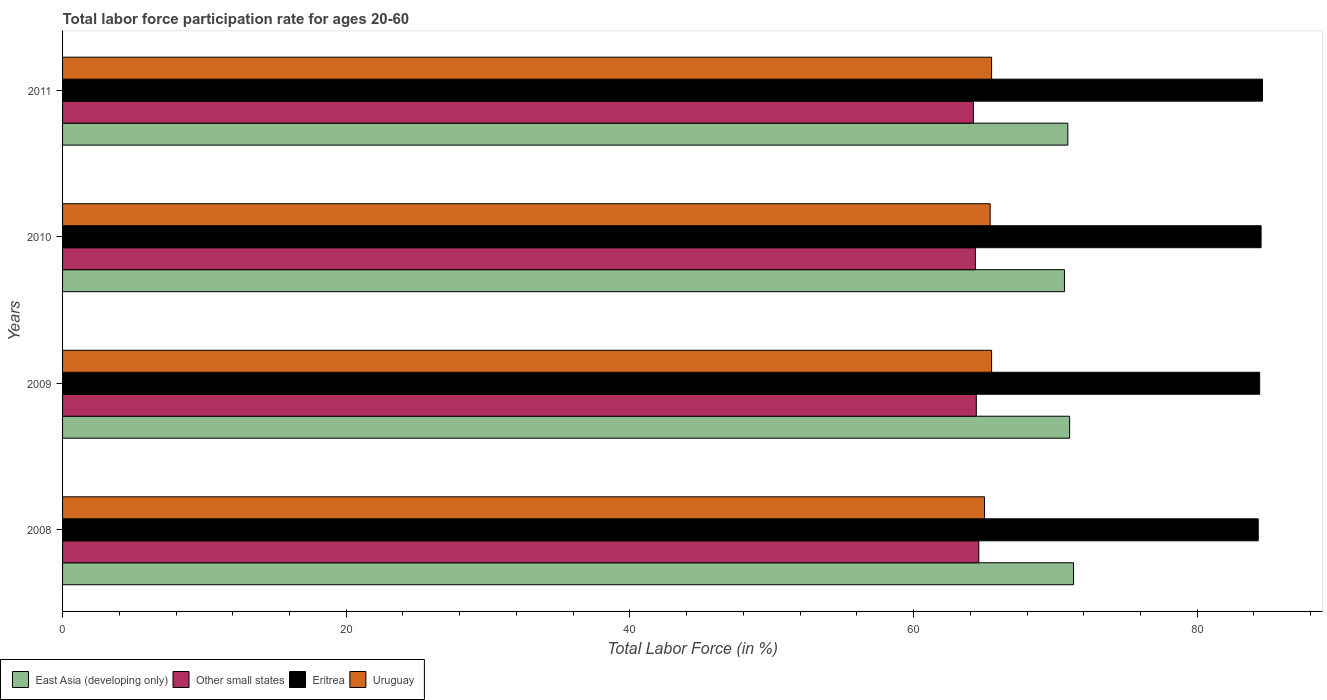How many groups of bars are there?
Make the answer very short. 4. Are the number of bars per tick equal to the number of legend labels?
Offer a terse response. Yes. Are the number of bars on each tick of the Y-axis equal?
Your response must be concise. Yes. How many bars are there on the 1st tick from the top?
Provide a short and direct response. 4. How many bars are there on the 4th tick from the bottom?
Offer a very short reply. 4. What is the label of the 4th group of bars from the top?
Ensure brevity in your answer.  2008. What is the labor force participation rate in East Asia (developing only) in 2011?
Ensure brevity in your answer.  70.87. Across all years, what is the maximum labor force participation rate in Eritrea?
Provide a short and direct response. 84.6. Across all years, what is the minimum labor force participation rate in Other small states?
Your response must be concise. 64.21. In which year was the labor force participation rate in Other small states minimum?
Ensure brevity in your answer.  2011. What is the total labor force participation rate in Eritrea in the graph?
Your answer should be compact. 337.8. What is the difference between the labor force participation rate in Eritrea in 2008 and that in 2009?
Your answer should be compact. -0.1. What is the difference between the labor force participation rate in East Asia (developing only) in 2010 and the labor force participation rate in Eritrea in 2011?
Offer a very short reply. -13.96. What is the average labor force participation rate in Uruguay per year?
Make the answer very short. 65.35. In the year 2009, what is the difference between the labor force participation rate in Other small states and labor force participation rate in East Asia (developing only)?
Your answer should be very brief. -6.58. What is the ratio of the labor force participation rate in Other small states in 2008 to that in 2009?
Your answer should be very brief. 1. Is the labor force participation rate in Other small states in 2009 less than that in 2011?
Keep it short and to the point. No. What is the difference between the highest and the second highest labor force participation rate in East Asia (developing only)?
Provide a short and direct response. 0.28. What is the difference between the highest and the lowest labor force participation rate in Uruguay?
Your answer should be very brief. 0.5. In how many years, is the labor force participation rate in Uruguay greater than the average labor force participation rate in Uruguay taken over all years?
Give a very brief answer. 3. Is the sum of the labor force participation rate in East Asia (developing only) in 2008 and 2009 greater than the maximum labor force participation rate in Uruguay across all years?
Keep it short and to the point. Yes. What does the 2nd bar from the top in 2009 represents?
Give a very brief answer. Eritrea. What does the 4th bar from the bottom in 2010 represents?
Give a very brief answer. Uruguay. Is it the case that in every year, the sum of the labor force participation rate in Other small states and labor force participation rate in East Asia (developing only) is greater than the labor force participation rate in Eritrea?
Offer a very short reply. Yes. How many bars are there?
Ensure brevity in your answer.  16. Are all the bars in the graph horizontal?
Give a very brief answer. Yes. How many years are there in the graph?
Make the answer very short. 4. What is the difference between two consecutive major ticks on the X-axis?
Give a very brief answer. 20. Are the values on the major ticks of X-axis written in scientific E-notation?
Your answer should be very brief. No. Where does the legend appear in the graph?
Offer a terse response. Bottom left. What is the title of the graph?
Your answer should be very brief. Total labor force participation rate for ages 20-60. What is the label or title of the Y-axis?
Offer a very short reply. Years. What is the Total Labor Force (in %) in East Asia (developing only) in 2008?
Keep it short and to the point. 71.28. What is the Total Labor Force (in %) of Other small states in 2008?
Your answer should be compact. 64.6. What is the Total Labor Force (in %) of Eritrea in 2008?
Make the answer very short. 84.3. What is the Total Labor Force (in %) in East Asia (developing only) in 2009?
Ensure brevity in your answer.  71. What is the Total Labor Force (in %) in Other small states in 2009?
Provide a short and direct response. 64.42. What is the Total Labor Force (in %) of Eritrea in 2009?
Provide a succinct answer. 84.4. What is the Total Labor Force (in %) of Uruguay in 2009?
Make the answer very short. 65.5. What is the Total Labor Force (in %) in East Asia (developing only) in 2010?
Keep it short and to the point. 70.64. What is the Total Labor Force (in %) of Other small states in 2010?
Offer a terse response. 64.36. What is the Total Labor Force (in %) in Eritrea in 2010?
Offer a terse response. 84.5. What is the Total Labor Force (in %) in Uruguay in 2010?
Provide a succinct answer. 65.4. What is the Total Labor Force (in %) of East Asia (developing only) in 2011?
Offer a terse response. 70.87. What is the Total Labor Force (in %) in Other small states in 2011?
Offer a very short reply. 64.21. What is the Total Labor Force (in %) of Eritrea in 2011?
Your response must be concise. 84.6. What is the Total Labor Force (in %) in Uruguay in 2011?
Ensure brevity in your answer.  65.5. Across all years, what is the maximum Total Labor Force (in %) in East Asia (developing only)?
Provide a short and direct response. 71.28. Across all years, what is the maximum Total Labor Force (in %) in Other small states?
Ensure brevity in your answer.  64.6. Across all years, what is the maximum Total Labor Force (in %) of Eritrea?
Give a very brief answer. 84.6. Across all years, what is the maximum Total Labor Force (in %) of Uruguay?
Give a very brief answer. 65.5. Across all years, what is the minimum Total Labor Force (in %) of East Asia (developing only)?
Provide a short and direct response. 70.64. Across all years, what is the minimum Total Labor Force (in %) in Other small states?
Keep it short and to the point. 64.21. Across all years, what is the minimum Total Labor Force (in %) in Eritrea?
Your answer should be very brief. 84.3. Across all years, what is the minimum Total Labor Force (in %) in Uruguay?
Provide a succinct answer. 65. What is the total Total Labor Force (in %) of East Asia (developing only) in the graph?
Ensure brevity in your answer.  283.79. What is the total Total Labor Force (in %) in Other small states in the graph?
Your answer should be compact. 257.6. What is the total Total Labor Force (in %) in Eritrea in the graph?
Provide a succinct answer. 337.8. What is the total Total Labor Force (in %) in Uruguay in the graph?
Your answer should be compact. 261.4. What is the difference between the Total Labor Force (in %) of East Asia (developing only) in 2008 and that in 2009?
Your answer should be compact. 0.28. What is the difference between the Total Labor Force (in %) of Other small states in 2008 and that in 2009?
Your response must be concise. 0.17. What is the difference between the Total Labor Force (in %) in East Asia (developing only) in 2008 and that in 2010?
Your answer should be very brief. 0.64. What is the difference between the Total Labor Force (in %) in Other small states in 2008 and that in 2010?
Make the answer very short. 0.24. What is the difference between the Total Labor Force (in %) in Eritrea in 2008 and that in 2010?
Offer a very short reply. -0.2. What is the difference between the Total Labor Force (in %) in Uruguay in 2008 and that in 2010?
Give a very brief answer. -0.4. What is the difference between the Total Labor Force (in %) of East Asia (developing only) in 2008 and that in 2011?
Provide a succinct answer. 0.4. What is the difference between the Total Labor Force (in %) in Other small states in 2008 and that in 2011?
Provide a short and direct response. 0.38. What is the difference between the Total Labor Force (in %) in East Asia (developing only) in 2009 and that in 2010?
Offer a terse response. 0.36. What is the difference between the Total Labor Force (in %) of Other small states in 2009 and that in 2010?
Your answer should be very brief. 0.06. What is the difference between the Total Labor Force (in %) in Uruguay in 2009 and that in 2010?
Make the answer very short. 0.1. What is the difference between the Total Labor Force (in %) of East Asia (developing only) in 2009 and that in 2011?
Ensure brevity in your answer.  0.13. What is the difference between the Total Labor Force (in %) in Other small states in 2009 and that in 2011?
Keep it short and to the point. 0.21. What is the difference between the Total Labor Force (in %) of East Asia (developing only) in 2010 and that in 2011?
Your answer should be very brief. -0.24. What is the difference between the Total Labor Force (in %) of Other small states in 2010 and that in 2011?
Your answer should be compact. 0.15. What is the difference between the Total Labor Force (in %) in Eritrea in 2010 and that in 2011?
Your answer should be very brief. -0.1. What is the difference between the Total Labor Force (in %) of East Asia (developing only) in 2008 and the Total Labor Force (in %) of Other small states in 2009?
Provide a short and direct response. 6.85. What is the difference between the Total Labor Force (in %) of East Asia (developing only) in 2008 and the Total Labor Force (in %) of Eritrea in 2009?
Give a very brief answer. -13.12. What is the difference between the Total Labor Force (in %) of East Asia (developing only) in 2008 and the Total Labor Force (in %) of Uruguay in 2009?
Your answer should be very brief. 5.78. What is the difference between the Total Labor Force (in %) of Other small states in 2008 and the Total Labor Force (in %) of Eritrea in 2009?
Provide a succinct answer. -19.8. What is the difference between the Total Labor Force (in %) of Other small states in 2008 and the Total Labor Force (in %) of Uruguay in 2009?
Your answer should be compact. -0.9. What is the difference between the Total Labor Force (in %) of East Asia (developing only) in 2008 and the Total Labor Force (in %) of Other small states in 2010?
Offer a very short reply. 6.91. What is the difference between the Total Labor Force (in %) of East Asia (developing only) in 2008 and the Total Labor Force (in %) of Eritrea in 2010?
Offer a very short reply. -13.22. What is the difference between the Total Labor Force (in %) of East Asia (developing only) in 2008 and the Total Labor Force (in %) of Uruguay in 2010?
Keep it short and to the point. 5.88. What is the difference between the Total Labor Force (in %) of Other small states in 2008 and the Total Labor Force (in %) of Eritrea in 2010?
Offer a terse response. -19.9. What is the difference between the Total Labor Force (in %) of Other small states in 2008 and the Total Labor Force (in %) of Uruguay in 2010?
Your response must be concise. -0.8. What is the difference between the Total Labor Force (in %) of East Asia (developing only) in 2008 and the Total Labor Force (in %) of Other small states in 2011?
Your answer should be very brief. 7.06. What is the difference between the Total Labor Force (in %) of East Asia (developing only) in 2008 and the Total Labor Force (in %) of Eritrea in 2011?
Provide a short and direct response. -13.32. What is the difference between the Total Labor Force (in %) of East Asia (developing only) in 2008 and the Total Labor Force (in %) of Uruguay in 2011?
Keep it short and to the point. 5.78. What is the difference between the Total Labor Force (in %) of Other small states in 2008 and the Total Labor Force (in %) of Eritrea in 2011?
Your answer should be very brief. -20. What is the difference between the Total Labor Force (in %) in Other small states in 2008 and the Total Labor Force (in %) in Uruguay in 2011?
Your answer should be compact. -0.9. What is the difference between the Total Labor Force (in %) of East Asia (developing only) in 2009 and the Total Labor Force (in %) of Other small states in 2010?
Make the answer very short. 6.64. What is the difference between the Total Labor Force (in %) of East Asia (developing only) in 2009 and the Total Labor Force (in %) of Eritrea in 2010?
Keep it short and to the point. -13.5. What is the difference between the Total Labor Force (in %) in East Asia (developing only) in 2009 and the Total Labor Force (in %) in Uruguay in 2010?
Make the answer very short. 5.6. What is the difference between the Total Labor Force (in %) in Other small states in 2009 and the Total Labor Force (in %) in Eritrea in 2010?
Your response must be concise. -20.08. What is the difference between the Total Labor Force (in %) of Other small states in 2009 and the Total Labor Force (in %) of Uruguay in 2010?
Keep it short and to the point. -0.98. What is the difference between the Total Labor Force (in %) of East Asia (developing only) in 2009 and the Total Labor Force (in %) of Other small states in 2011?
Offer a very short reply. 6.79. What is the difference between the Total Labor Force (in %) in East Asia (developing only) in 2009 and the Total Labor Force (in %) in Eritrea in 2011?
Give a very brief answer. -13.6. What is the difference between the Total Labor Force (in %) in East Asia (developing only) in 2009 and the Total Labor Force (in %) in Uruguay in 2011?
Your answer should be very brief. 5.5. What is the difference between the Total Labor Force (in %) of Other small states in 2009 and the Total Labor Force (in %) of Eritrea in 2011?
Give a very brief answer. -20.18. What is the difference between the Total Labor Force (in %) of Other small states in 2009 and the Total Labor Force (in %) of Uruguay in 2011?
Make the answer very short. -1.08. What is the difference between the Total Labor Force (in %) in East Asia (developing only) in 2010 and the Total Labor Force (in %) in Other small states in 2011?
Keep it short and to the point. 6.42. What is the difference between the Total Labor Force (in %) of East Asia (developing only) in 2010 and the Total Labor Force (in %) of Eritrea in 2011?
Give a very brief answer. -13.96. What is the difference between the Total Labor Force (in %) of East Asia (developing only) in 2010 and the Total Labor Force (in %) of Uruguay in 2011?
Ensure brevity in your answer.  5.14. What is the difference between the Total Labor Force (in %) of Other small states in 2010 and the Total Labor Force (in %) of Eritrea in 2011?
Provide a short and direct response. -20.24. What is the difference between the Total Labor Force (in %) of Other small states in 2010 and the Total Labor Force (in %) of Uruguay in 2011?
Your answer should be very brief. -1.14. What is the average Total Labor Force (in %) in East Asia (developing only) per year?
Give a very brief answer. 70.95. What is the average Total Labor Force (in %) of Other small states per year?
Offer a terse response. 64.4. What is the average Total Labor Force (in %) of Eritrea per year?
Your response must be concise. 84.45. What is the average Total Labor Force (in %) in Uruguay per year?
Provide a succinct answer. 65.35. In the year 2008, what is the difference between the Total Labor Force (in %) in East Asia (developing only) and Total Labor Force (in %) in Other small states?
Your answer should be very brief. 6.68. In the year 2008, what is the difference between the Total Labor Force (in %) in East Asia (developing only) and Total Labor Force (in %) in Eritrea?
Offer a very short reply. -13.02. In the year 2008, what is the difference between the Total Labor Force (in %) of East Asia (developing only) and Total Labor Force (in %) of Uruguay?
Give a very brief answer. 6.28. In the year 2008, what is the difference between the Total Labor Force (in %) in Other small states and Total Labor Force (in %) in Eritrea?
Your answer should be compact. -19.7. In the year 2008, what is the difference between the Total Labor Force (in %) of Other small states and Total Labor Force (in %) of Uruguay?
Offer a very short reply. -0.4. In the year 2008, what is the difference between the Total Labor Force (in %) of Eritrea and Total Labor Force (in %) of Uruguay?
Provide a short and direct response. 19.3. In the year 2009, what is the difference between the Total Labor Force (in %) of East Asia (developing only) and Total Labor Force (in %) of Other small states?
Offer a terse response. 6.58. In the year 2009, what is the difference between the Total Labor Force (in %) of East Asia (developing only) and Total Labor Force (in %) of Eritrea?
Ensure brevity in your answer.  -13.4. In the year 2009, what is the difference between the Total Labor Force (in %) of East Asia (developing only) and Total Labor Force (in %) of Uruguay?
Give a very brief answer. 5.5. In the year 2009, what is the difference between the Total Labor Force (in %) in Other small states and Total Labor Force (in %) in Eritrea?
Provide a succinct answer. -19.98. In the year 2009, what is the difference between the Total Labor Force (in %) in Other small states and Total Labor Force (in %) in Uruguay?
Make the answer very short. -1.08. In the year 2010, what is the difference between the Total Labor Force (in %) in East Asia (developing only) and Total Labor Force (in %) in Other small states?
Provide a short and direct response. 6.28. In the year 2010, what is the difference between the Total Labor Force (in %) of East Asia (developing only) and Total Labor Force (in %) of Eritrea?
Your response must be concise. -13.86. In the year 2010, what is the difference between the Total Labor Force (in %) of East Asia (developing only) and Total Labor Force (in %) of Uruguay?
Your response must be concise. 5.24. In the year 2010, what is the difference between the Total Labor Force (in %) of Other small states and Total Labor Force (in %) of Eritrea?
Your answer should be compact. -20.14. In the year 2010, what is the difference between the Total Labor Force (in %) in Other small states and Total Labor Force (in %) in Uruguay?
Your answer should be very brief. -1.04. In the year 2011, what is the difference between the Total Labor Force (in %) in East Asia (developing only) and Total Labor Force (in %) in Other small states?
Offer a terse response. 6.66. In the year 2011, what is the difference between the Total Labor Force (in %) in East Asia (developing only) and Total Labor Force (in %) in Eritrea?
Provide a short and direct response. -13.73. In the year 2011, what is the difference between the Total Labor Force (in %) in East Asia (developing only) and Total Labor Force (in %) in Uruguay?
Provide a succinct answer. 5.37. In the year 2011, what is the difference between the Total Labor Force (in %) in Other small states and Total Labor Force (in %) in Eritrea?
Make the answer very short. -20.39. In the year 2011, what is the difference between the Total Labor Force (in %) of Other small states and Total Labor Force (in %) of Uruguay?
Give a very brief answer. -1.29. What is the ratio of the Total Labor Force (in %) of Eritrea in 2008 to that in 2009?
Keep it short and to the point. 1. What is the ratio of the Total Labor Force (in %) of Eritrea in 2008 to that in 2011?
Give a very brief answer. 1. What is the ratio of the Total Labor Force (in %) of Other small states in 2009 to that in 2010?
Your answer should be very brief. 1. What is the ratio of the Total Labor Force (in %) of Uruguay in 2009 to that in 2010?
Offer a terse response. 1. What is the ratio of the Total Labor Force (in %) in Eritrea in 2009 to that in 2011?
Ensure brevity in your answer.  1. What is the ratio of the Total Labor Force (in %) in Uruguay in 2009 to that in 2011?
Your answer should be very brief. 1. What is the difference between the highest and the second highest Total Labor Force (in %) of East Asia (developing only)?
Offer a very short reply. 0.28. What is the difference between the highest and the second highest Total Labor Force (in %) of Other small states?
Your response must be concise. 0.17. What is the difference between the highest and the second highest Total Labor Force (in %) of Uruguay?
Your answer should be very brief. 0. What is the difference between the highest and the lowest Total Labor Force (in %) in East Asia (developing only)?
Offer a terse response. 0.64. What is the difference between the highest and the lowest Total Labor Force (in %) of Other small states?
Give a very brief answer. 0.38. What is the difference between the highest and the lowest Total Labor Force (in %) of Uruguay?
Provide a succinct answer. 0.5. 